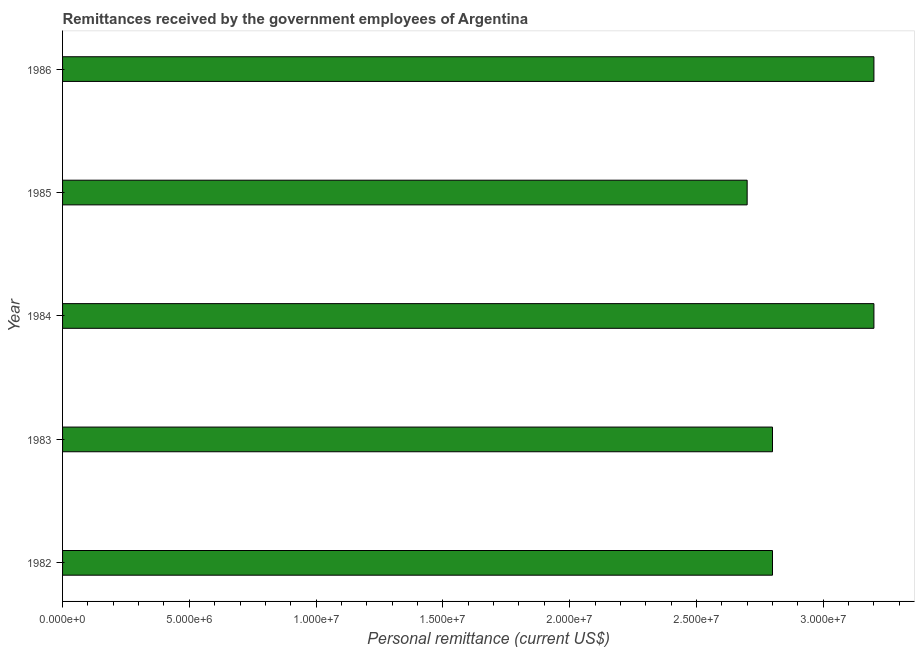Does the graph contain grids?
Your answer should be very brief. No. What is the title of the graph?
Your answer should be very brief. Remittances received by the government employees of Argentina. What is the label or title of the X-axis?
Give a very brief answer. Personal remittance (current US$). What is the personal remittances in 1985?
Your response must be concise. 2.70e+07. Across all years, what is the maximum personal remittances?
Provide a short and direct response. 3.20e+07. Across all years, what is the minimum personal remittances?
Offer a terse response. 2.70e+07. In which year was the personal remittances minimum?
Your answer should be very brief. 1985. What is the sum of the personal remittances?
Your response must be concise. 1.47e+08. What is the difference between the personal remittances in 1982 and 1984?
Keep it short and to the point. -4.00e+06. What is the average personal remittances per year?
Offer a very short reply. 2.94e+07. What is the median personal remittances?
Your response must be concise. 2.80e+07. In how many years, is the personal remittances greater than 25000000 US$?
Provide a short and direct response. 5. Is the personal remittances in 1983 less than that in 1985?
Provide a short and direct response. No. What is the difference between the highest and the lowest personal remittances?
Your answer should be compact. 5.00e+06. In how many years, is the personal remittances greater than the average personal remittances taken over all years?
Your answer should be compact. 2. How many bars are there?
Offer a terse response. 5. Are all the bars in the graph horizontal?
Keep it short and to the point. Yes. What is the Personal remittance (current US$) in 1982?
Keep it short and to the point. 2.80e+07. What is the Personal remittance (current US$) in 1983?
Provide a succinct answer. 2.80e+07. What is the Personal remittance (current US$) of 1984?
Ensure brevity in your answer.  3.20e+07. What is the Personal remittance (current US$) of 1985?
Make the answer very short. 2.70e+07. What is the Personal remittance (current US$) of 1986?
Make the answer very short. 3.20e+07. What is the difference between the Personal remittance (current US$) in 1982 and 1984?
Your response must be concise. -4.00e+06. What is the difference between the Personal remittance (current US$) in 1983 and 1984?
Make the answer very short. -4.00e+06. What is the difference between the Personal remittance (current US$) in 1984 and 1986?
Ensure brevity in your answer.  0. What is the difference between the Personal remittance (current US$) in 1985 and 1986?
Ensure brevity in your answer.  -5.00e+06. What is the ratio of the Personal remittance (current US$) in 1982 to that in 1984?
Your response must be concise. 0.88. What is the ratio of the Personal remittance (current US$) in 1983 to that in 1986?
Your answer should be very brief. 0.88. What is the ratio of the Personal remittance (current US$) in 1984 to that in 1985?
Give a very brief answer. 1.19. What is the ratio of the Personal remittance (current US$) in 1984 to that in 1986?
Your answer should be very brief. 1. What is the ratio of the Personal remittance (current US$) in 1985 to that in 1986?
Keep it short and to the point. 0.84. 